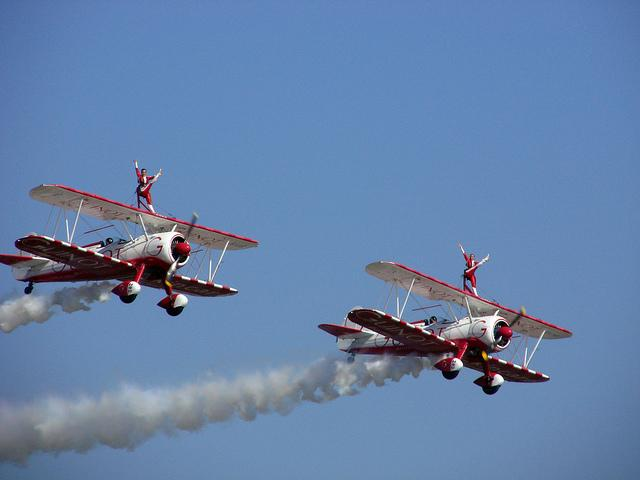What profession do the people on top of the planes belong to? Please explain your reasoning. acrobats. There are people doing tricks on top of the planes. 